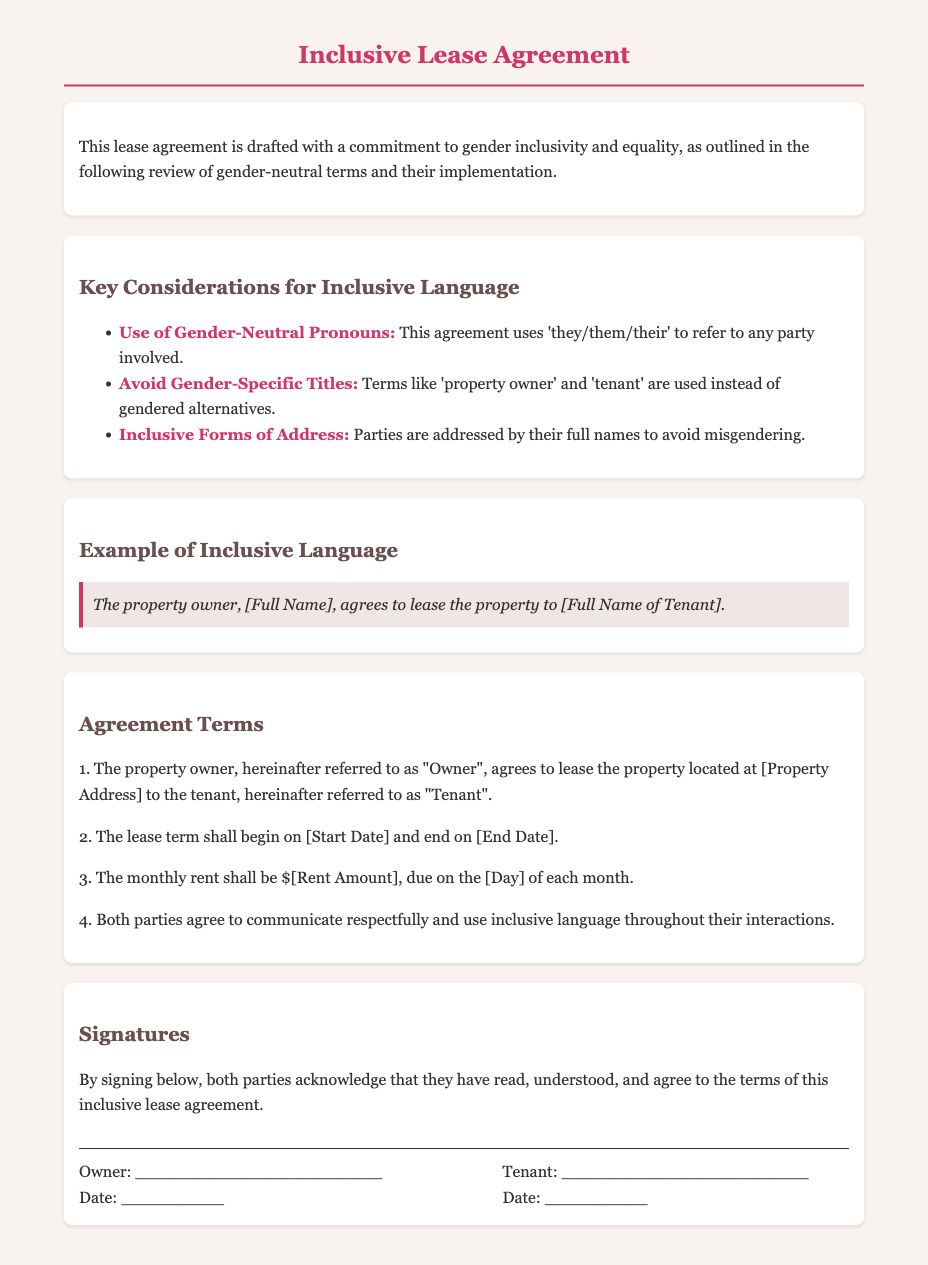What is the title of the document? The title of the document is prominently displayed at the top and serves as the main subject.
Answer: Inclusive Lease Agreement Who is referred to as "Owner" in the agreement? "Owner" in the agreement refers to the property owner, which is stated in the terms.
Answer: property owner What is the gender-neutral pronoun used in the agreement? The document explicitly states the use of 'they/them/their' as the gender-neutral pronoun.
Answer: they/them/their What does the lease agreement require both parties to do? This is outlined in the terms of the agreement, emphasizing mutual communication standards.
Answer: communicate respectfully What is the effective date of the lease agreement? The effective date is determined by the start date mentioned in the terms of the agreement.
Answer: [Start Date] What is the monthly rent due? The monthly rent amount is specified and is part of the agreement terms.
Answer: $[Rent Amount] How many signatures are required on the lease? The document specifies the need for both parties to sign for validation.
Answer: Two signatures What example is given for inclusive language? The example illustrates how parties are named in a gender-neutral form within the agreement.
Answer: The property owner, [Full Name], agrees to lease the property to [Full Name of Tenant] What is the background color of the document? The background color provides a subtle and calming setting for readability, reflected in the style section.
Answer: #f9f3f0 